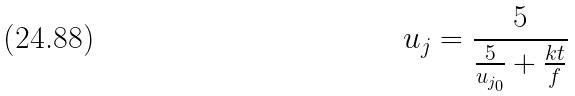<formula> <loc_0><loc_0><loc_500><loc_500>u _ { j } = \frac { 5 } { \frac { 5 } { u _ { j _ { 0 } } } + \frac { k t } { f } }</formula> 